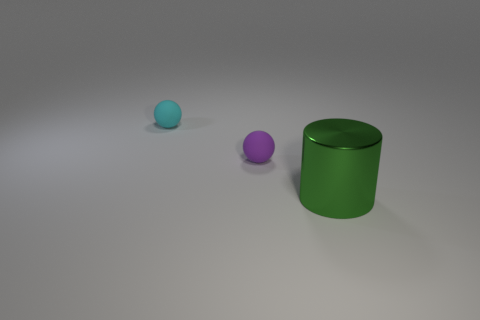Add 1 purple things. How many objects exist? 4 Subtract all balls. How many objects are left? 1 Add 1 cyan matte things. How many cyan matte things are left? 2 Add 2 large green cylinders. How many large green cylinders exist? 3 Subtract 0 yellow cylinders. How many objects are left? 3 Subtract 1 cylinders. How many cylinders are left? 0 Subtract all brown balls. Subtract all purple cylinders. How many balls are left? 2 Subtract all gray cylinders. How many purple spheres are left? 1 Subtract all large cyan metal cylinders. Subtract all small spheres. How many objects are left? 1 